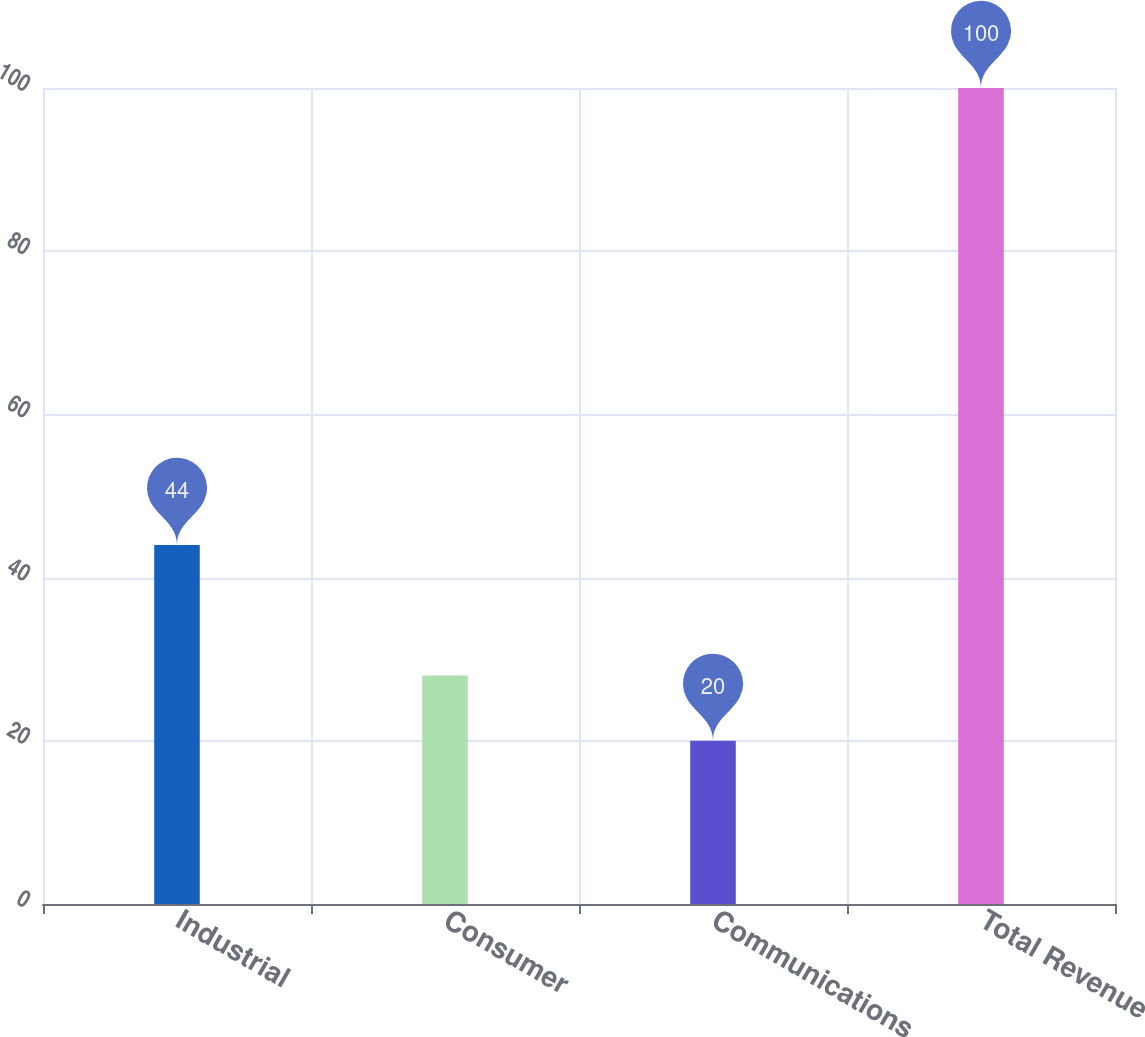Convert chart to OTSL. <chart><loc_0><loc_0><loc_500><loc_500><bar_chart><fcel>Industrial<fcel>Consumer<fcel>Communications<fcel>Total Revenue<nl><fcel>44<fcel>28<fcel>20<fcel>100<nl></chart> 